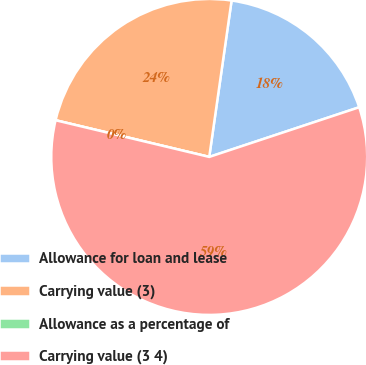Convert chart. <chart><loc_0><loc_0><loc_500><loc_500><pie_chart><fcel>Allowance for loan and lease<fcel>Carrying value (3)<fcel>Allowance as a percentage of<fcel>Carrying value (3 4)<nl><fcel>17.65%<fcel>23.53%<fcel>0.0%<fcel>58.82%<nl></chart> 